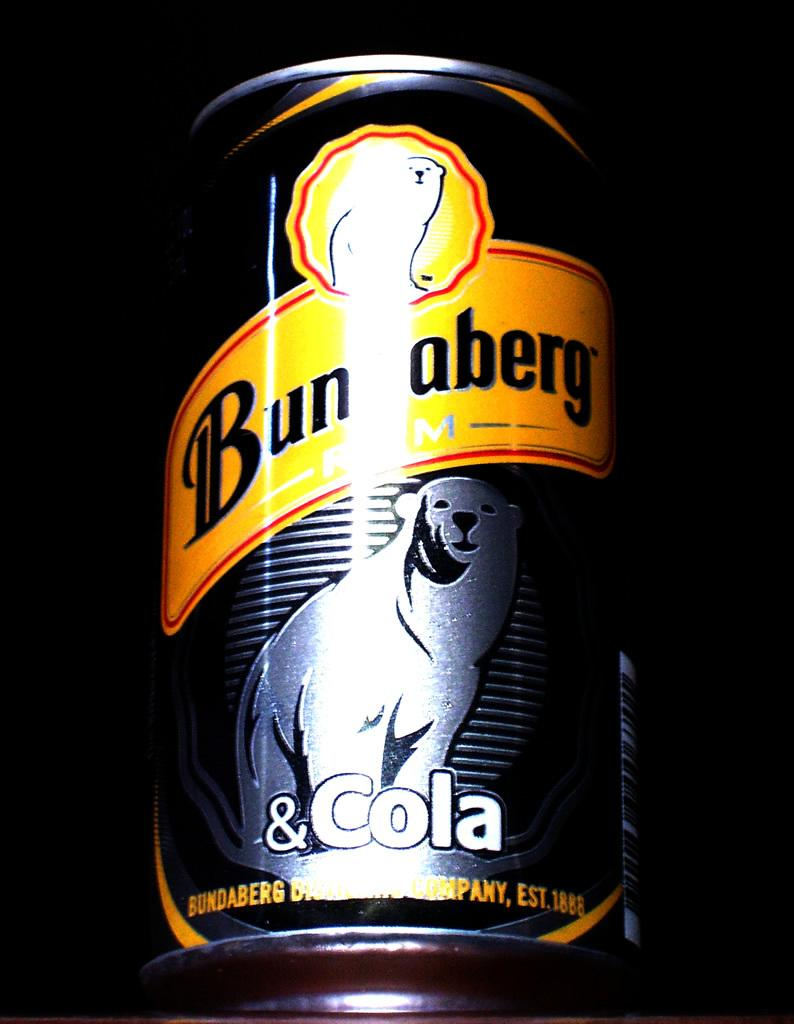<image>
Summarize the visual content of the image. A can has a picture of a bear and Cola at the bottom. 